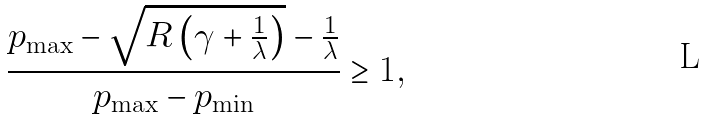<formula> <loc_0><loc_0><loc_500><loc_500>\frac { p _ { \max } - \sqrt { R \left ( \gamma + \frac { 1 } { \lambda } \right ) } - \frac { 1 } { \lambda } } { p _ { \max } - p _ { \min } } \geq 1 ,</formula> 